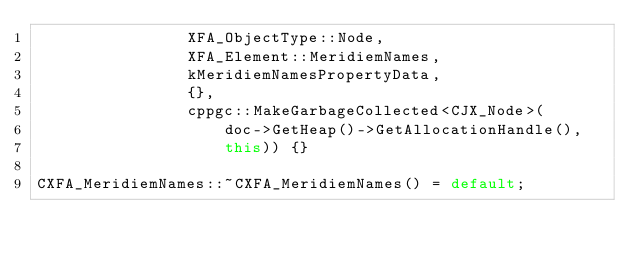Convert code to text. <code><loc_0><loc_0><loc_500><loc_500><_C++_>                XFA_ObjectType::Node,
                XFA_Element::MeridiemNames,
                kMeridiemNamesPropertyData,
                {},
                cppgc::MakeGarbageCollected<CJX_Node>(
                    doc->GetHeap()->GetAllocationHandle(),
                    this)) {}

CXFA_MeridiemNames::~CXFA_MeridiemNames() = default;
</code> 